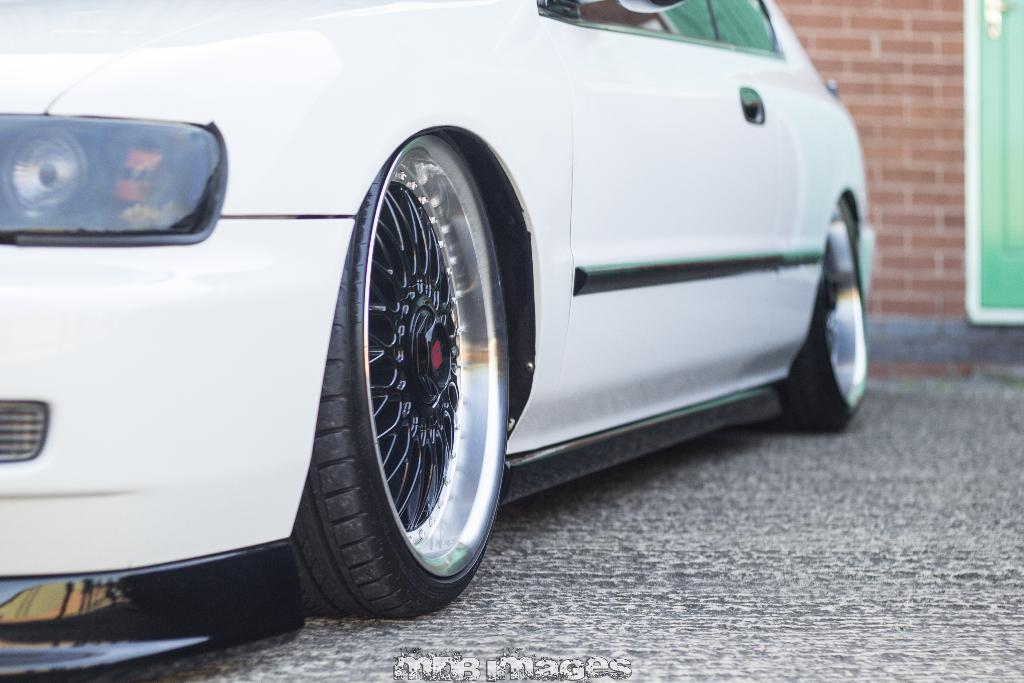What type of vehicle is in the image? There is a white car in the image. What is the car doing in the image? The car is parked. What is the background of the image made of? There is a brick wall in the image. Is there any entrance or exit visible in the image? Yes, there is a door in the image. What type of school can be seen in the image? There is no school present in the image. How many planes are visible in the image? There are no planes visible in the image. What type of health advice can be seen in the image? There is no health advice present in the image. 